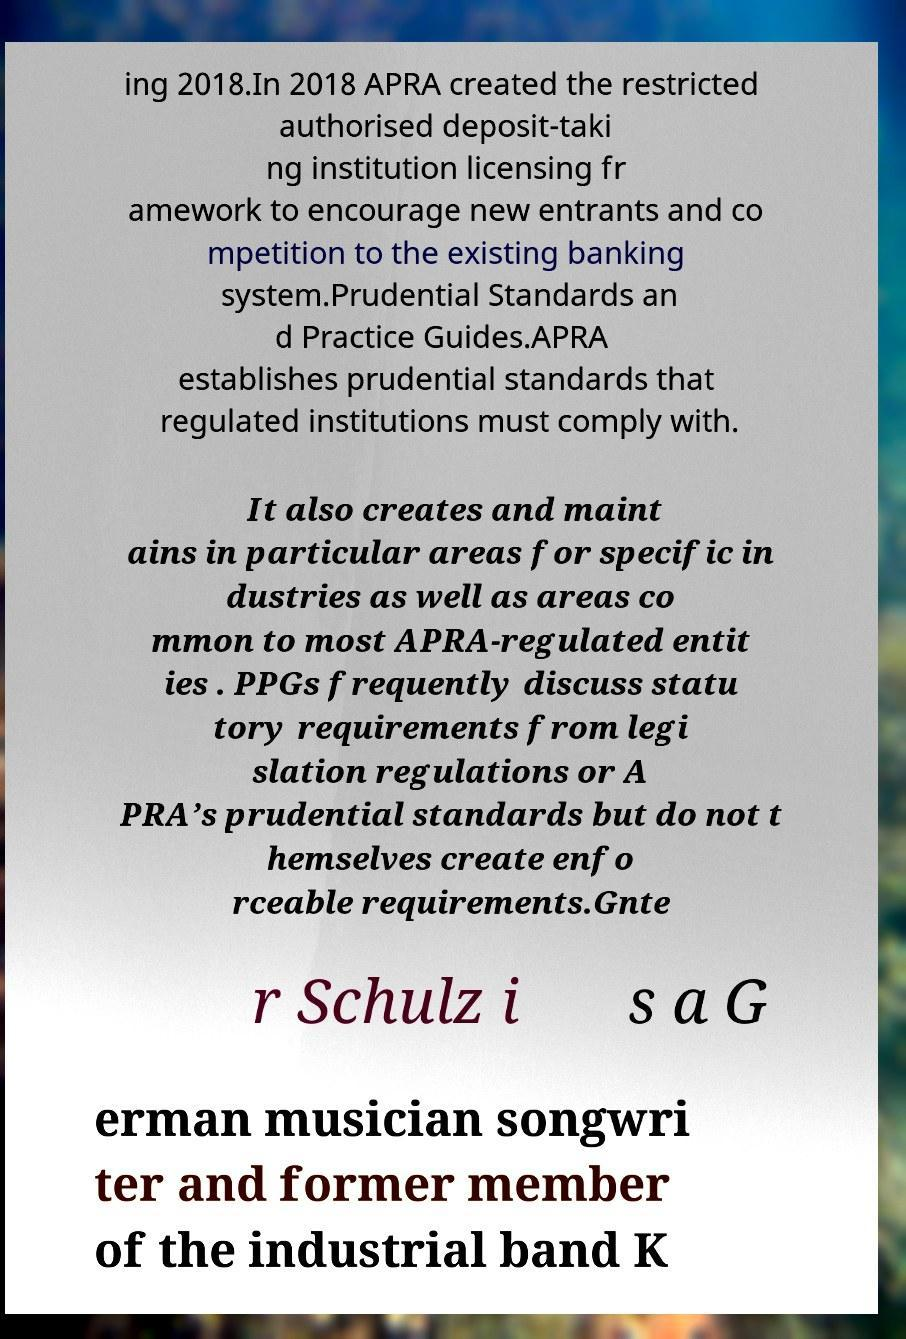I need the written content from this picture converted into text. Can you do that? ing 2018.In 2018 APRA created the restricted authorised deposit-taki ng institution licensing fr amework to encourage new entrants and co mpetition to the existing banking system.Prudential Standards an d Practice Guides.APRA establishes prudential standards that regulated institutions must comply with. It also creates and maint ains in particular areas for specific in dustries as well as areas co mmon to most APRA-regulated entit ies . PPGs frequently discuss statu tory requirements from legi slation regulations or A PRA’s prudential standards but do not t hemselves create enfo rceable requirements.Gnte r Schulz i s a G erman musician songwri ter and former member of the industrial band K 